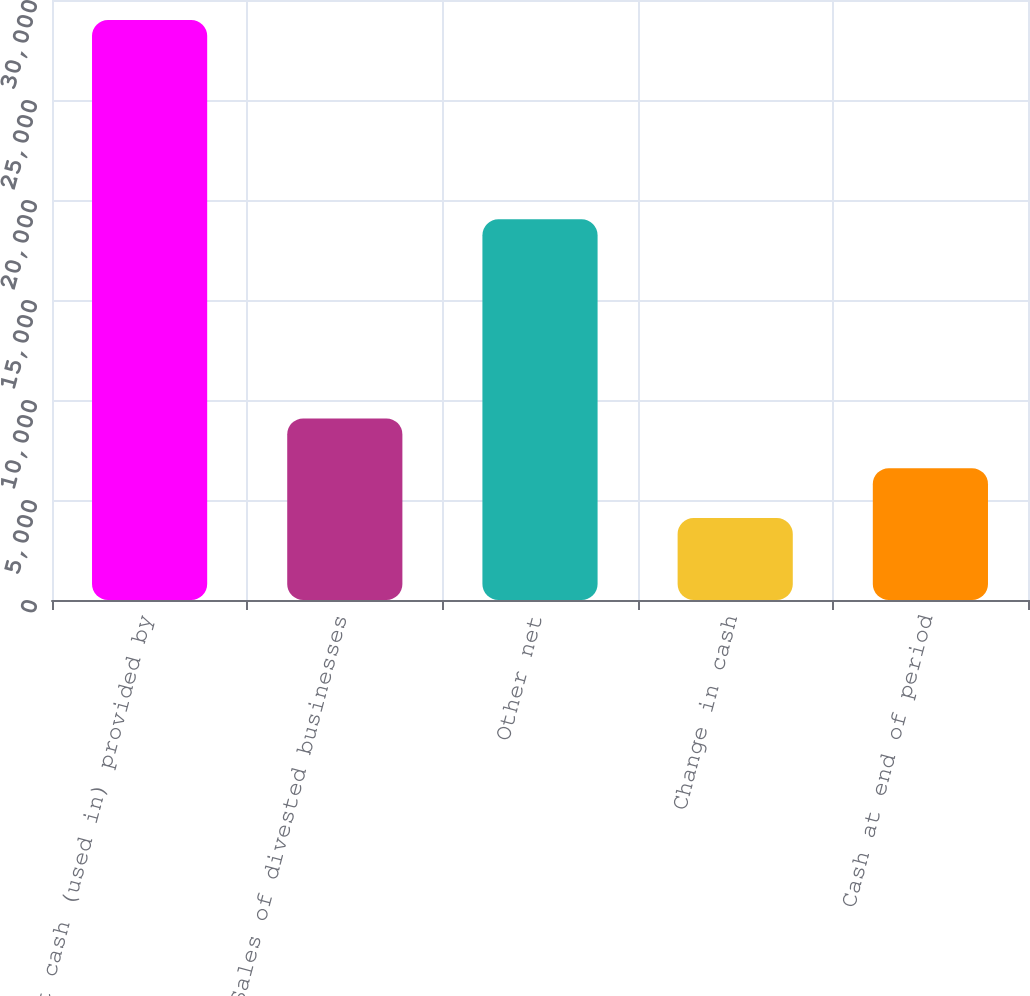<chart> <loc_0><loc_0><loc_500><loc_500><bar_chart><fcel>Net cash (used in) provided by<fcel>Sales of divested businesses<fcel>Other net<fcel>Change in cash<fcel>Cash at end of period<nl><fcel>28997<fcel>9081<fcel>19039<fcel>4102<fcel>6591.5<nl></chart> 